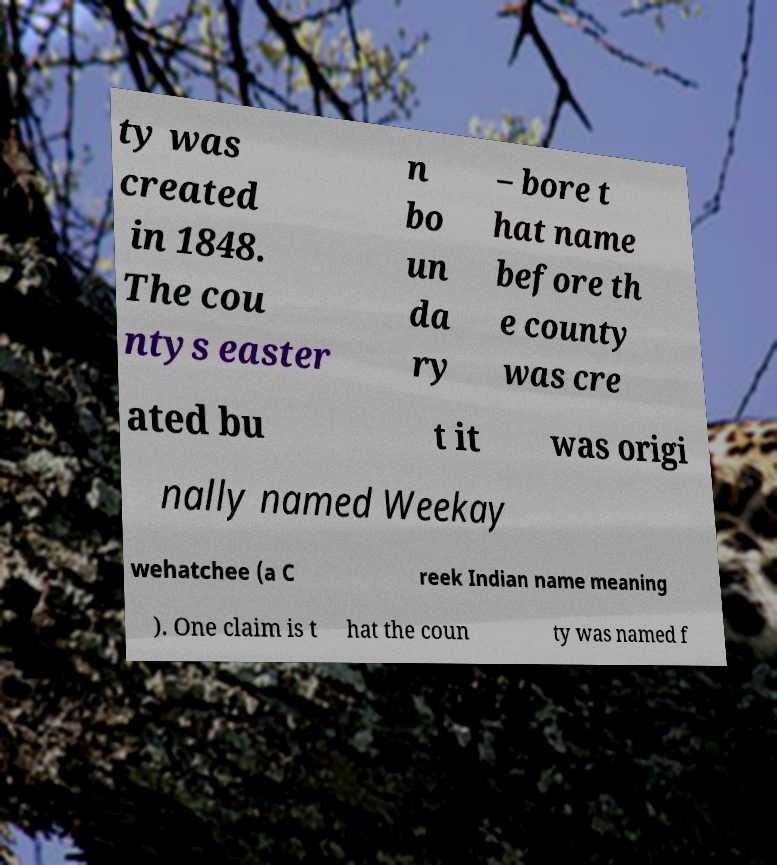Can you accurately transcribe the text from the provided image for me? ty was created in 1848. The cou ntys easter n bo un da ry – bore t hat name before th e county was cre ated bu t it was origi nally named Weekay wehatchee (a C reek Indian name meaning ). One claim is t hat the coun ty was named f 